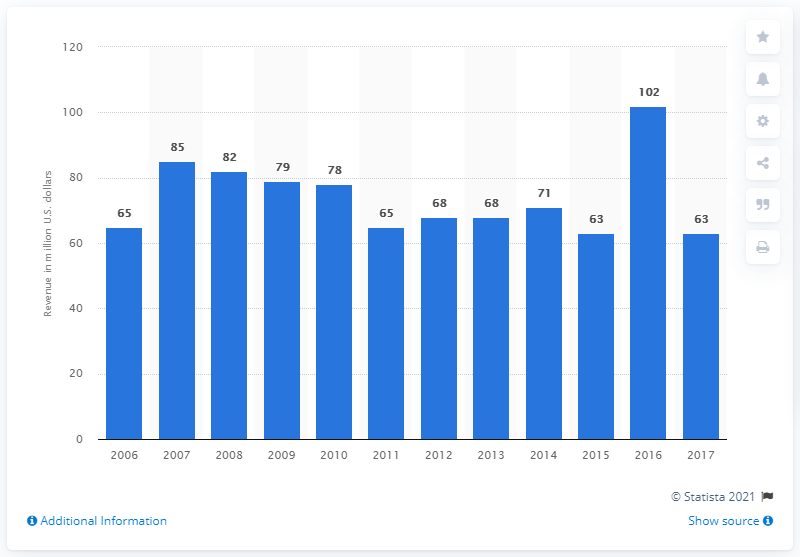Identify some key points in this picture. In 2011, the revenue of Penske Racing was approximately $65 million. 